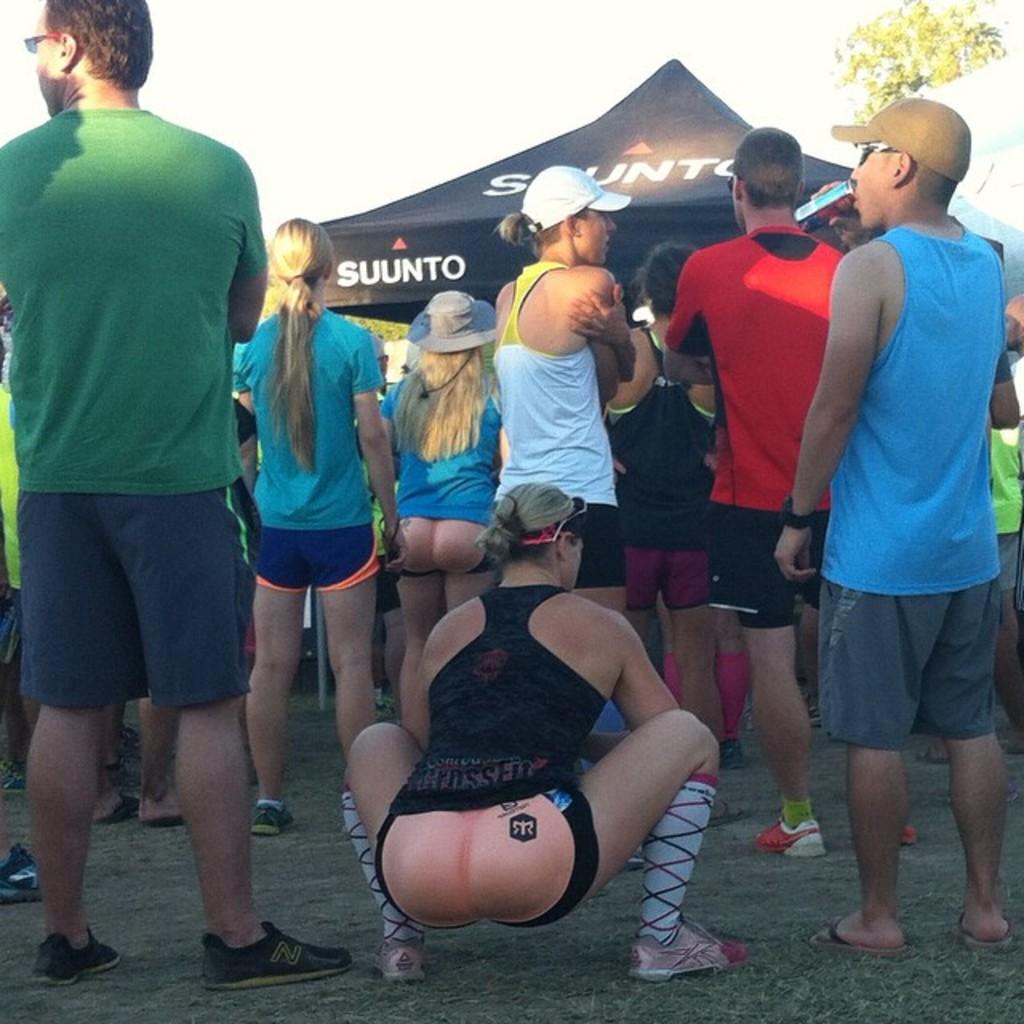What company name is on the tent?
Ensure brevity in your answer.  Suunto. 